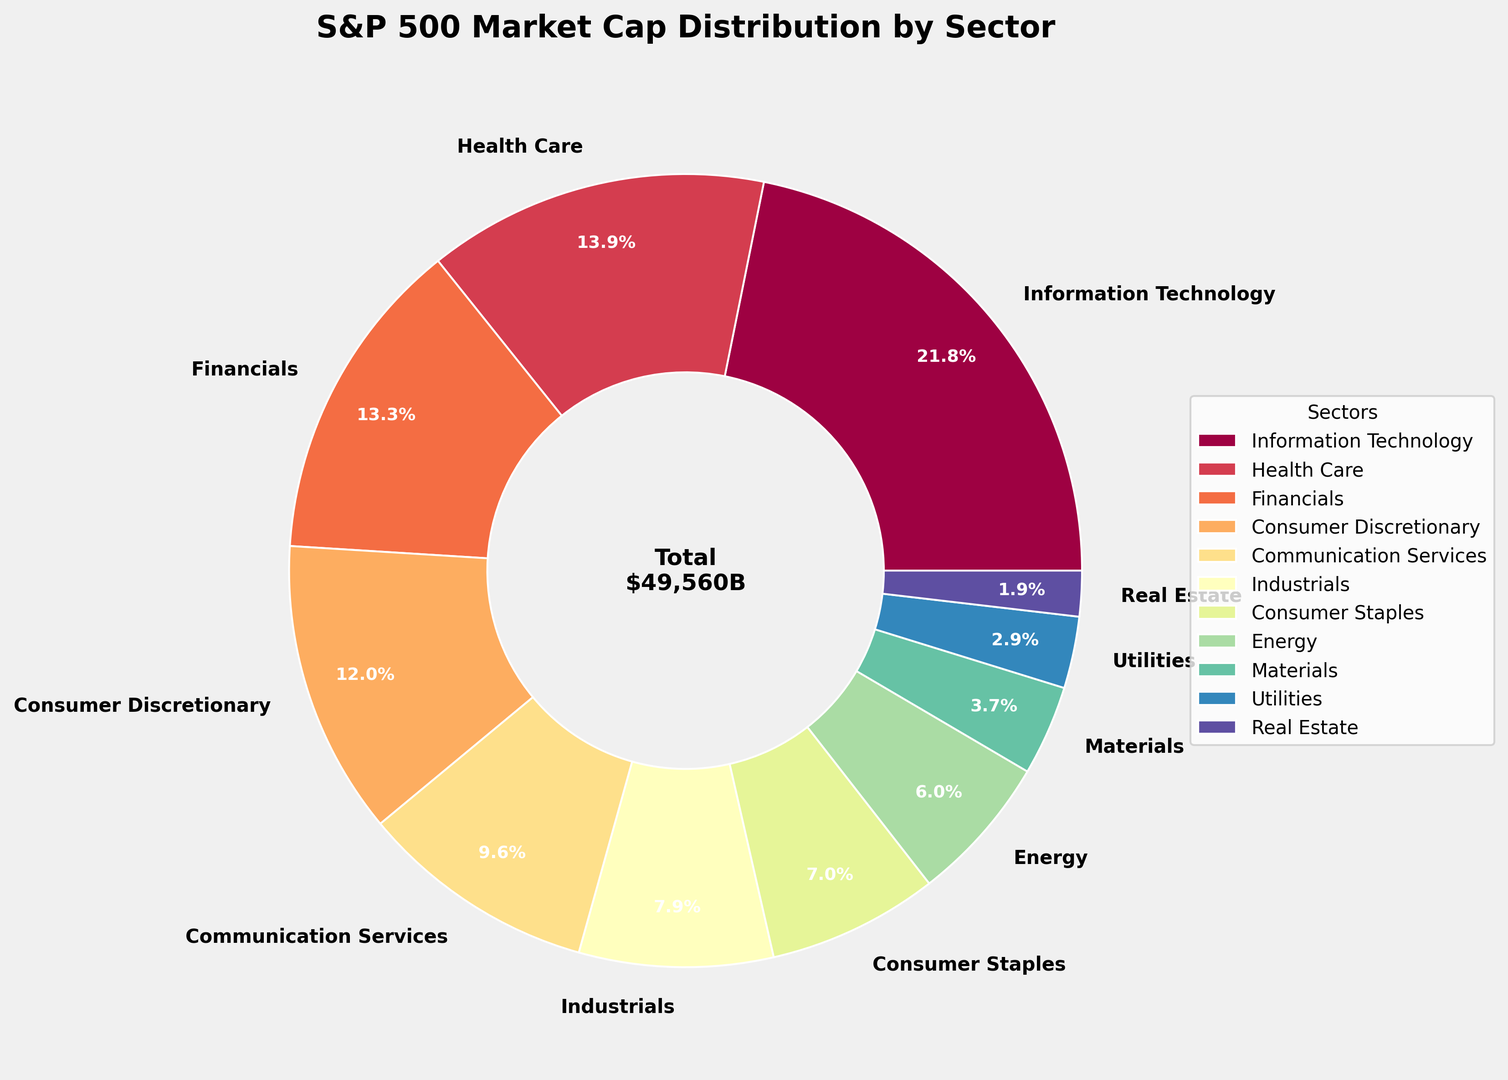Which sector has the highest market cap? The figure shows the percentage of market cap by sector. The sector with the largest wedge corresponds to Information Technology.
Answer: Information Technology Which sector has the smallest market cap? The figure indicates that the smallest wedge corresponds to Real Estate.
Answer: Real Estate By how much is the market cap of Information Technology larger than that of Financials? Information Technology's market cap is $10,820 billion, and Financials' market cap is $6,580 billion. The difference is $10,820 billion - $6,580 billion.
Answer: $4,240 billion What is the combined market cap of Health Care and Communication Services? Health Care's market cap is $6,890 billion, and Communication Services' market cap is $4,780 billion. Their combined market cap is $6,890 billion + $4,780 billion.
Answer: $11,670 billion Which sector has a market cap closest to $4,000 billion? The figure indicates that Industrials have a market cap of $3,920 billion, which is the closest to $4,000 billion.
Answer: Industrials Which sector occupies a greater percentage of the market cap, Energy or Utilities? The figure shows that Energy has a larger wedge than Utilities, indicating a greater market cap percentage.
Answer: Energy How does the size of the market cap in Consumer Discretionary compare to Consumer Staples? The figure shows that the wedge for Consumer Discretionary is larger than that for Consumer Staples, indicating a higher market cap.
Answer: Consumer Discretionary has a higher market cap If the market cap of Information Technology were to increase by 10%, what would be its new market cap? The current market cap of Information Technology is $10,820 billion. An increase of 10% is $10,820 billion * 0.1 = $1,082 billion. The new market cap would be $10,820 billion + $1,082 billion.
Answer: $11,902 billion What is the average market cap of the sectors with market caps over $5,000 billion? The sectors are Information Technology ($10,820 billion), Health Care ($6,890 billion), and Financials ($6,580 billion). Their average is ($10,820 billion + $6,890 billion + $6,580 billion) / 3.
Answer: $8,097 billion 